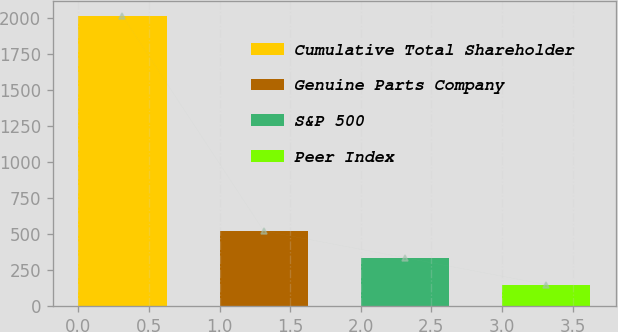Convert chart to OTSL. <chart><loc_0><loc_0><loc_500><loc_500><bar_chart><fcel>Cumulative Total Shareholder<fcel>Genuine Parts Company<fcel>S&P 500<fcel>Peer Index<nl><fcel>2014<fcel>521.66<fcel>335.12<fcel>148.58<nl></chart> 